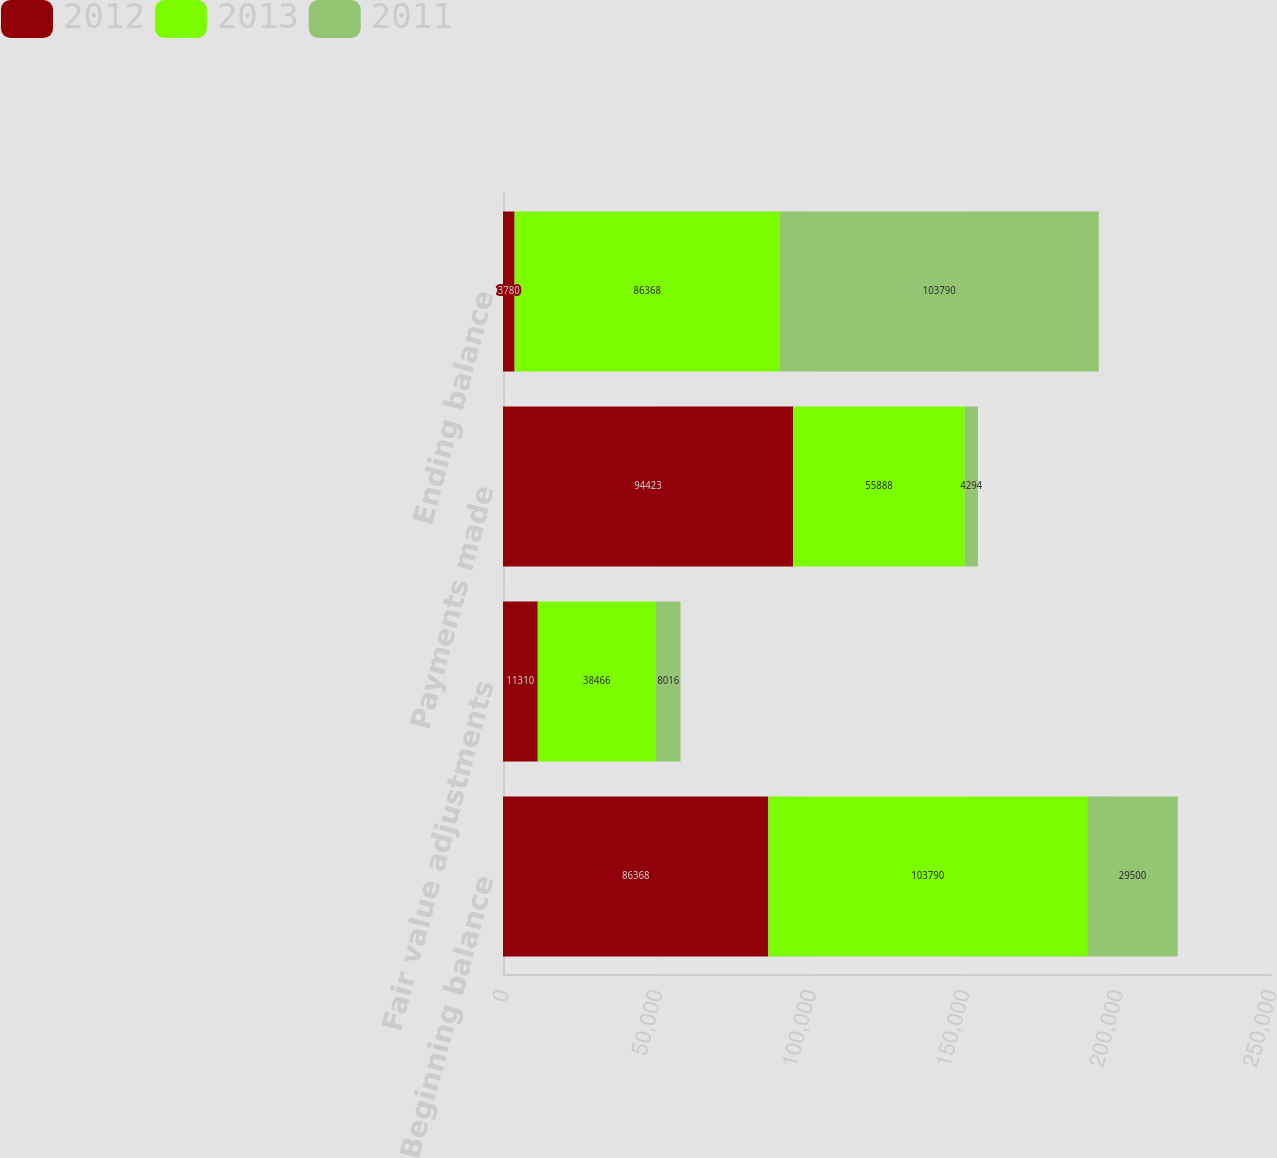Convert chart to OTSL. <chart><loc_0><loc_0><loc_500><loc_500><stacked_bar_chart><ecel><fcel>Beginning balance<fcel>Fair value adjustments<fcel>Payments made<fcel>Ending balance<nl><fcel>2012<fcel>86368<fcel>11310<fcel>94423<fcel>3780<nl><fcel>2013<fcel>103790<fcel>38466<fcel>55888<fcel>86368<nl><fcel>2011<fcel>29500<fcel>8016<fcel>4294<fcel>103790<nl></chart> 